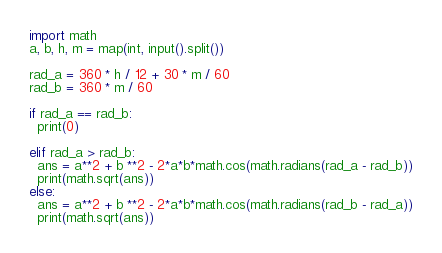<code> <loc_0><loc_0><loc_500><loc_500><_Python_>import math
a, b, h, m = map(int, input().split())

rad_a = 360 * h / 12 + 30 * m / 60
rad_b = 360 * m / 60 

if rad_a == rad_b:
  print(0)
  
elif rad_a > rad_b:
  ans = a**2 + b **2 - 2*a*b*math.cos(math.radians(rad_a - rad_b))
  print(math.sqrt(ans))
else:
  ans = a**2 + b **2 - 2*a*b*math.cos(math.radians(rad_b - rad_a))
  print(math.sqrt(ans))</code> 